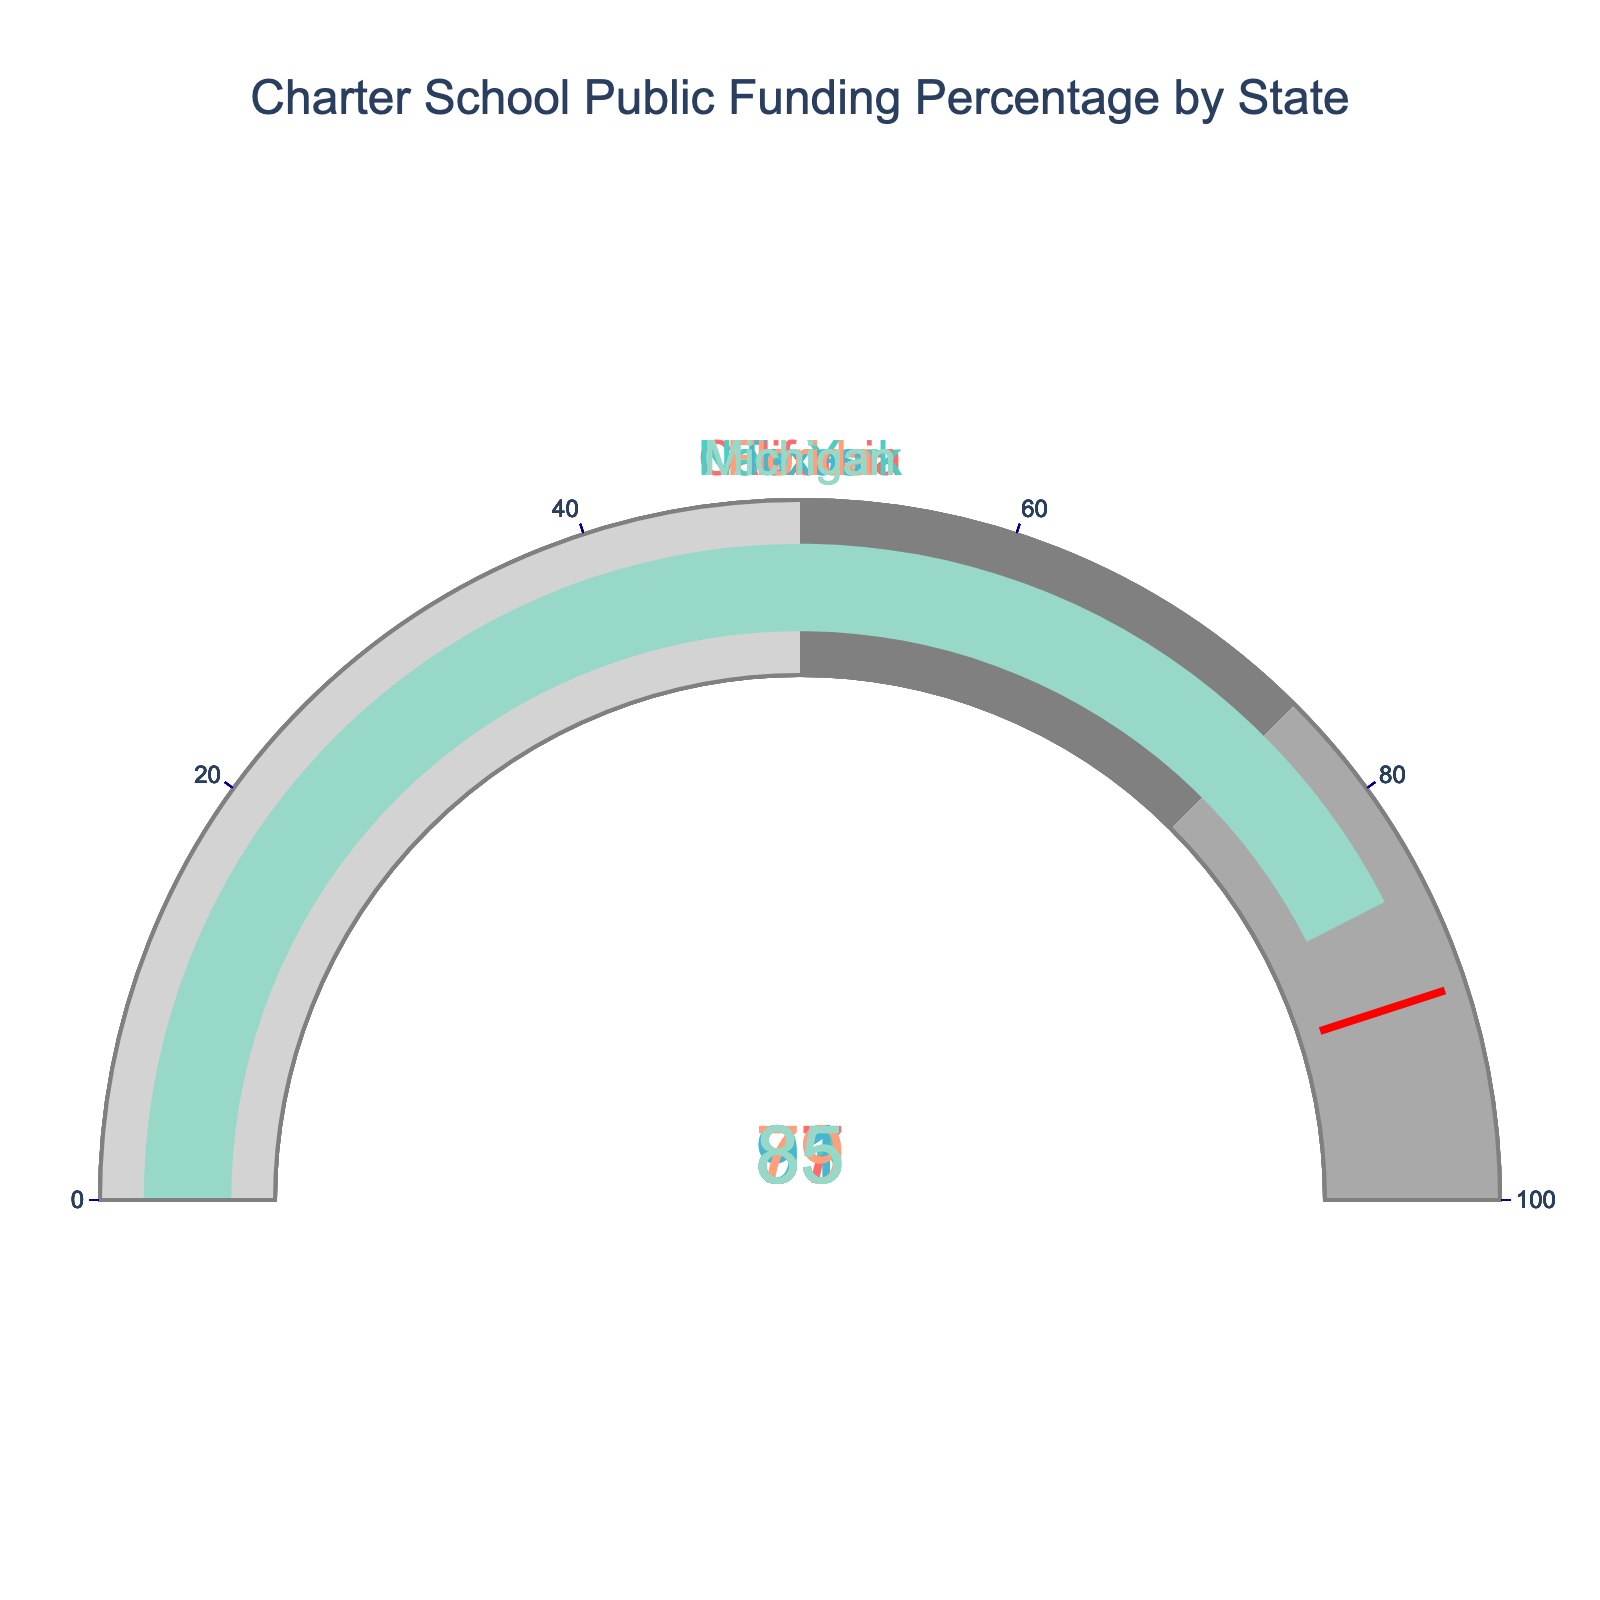what is the title of the figure? The title is displayed at the top of the figure, written in large font. It reads "Charter School Public Funding Percentage by State".
Answer: Charter School Public Funding Percentage by State Which state has the highest percentage of charter school funding from public sources? By looking at the gauge chart, you can compare the displayed percentages for each state. Texas has the highest value, which is 91%.
Answer: Texas How many states have more than 80% of their charter school funding coming from public sources? Look at the percentages on the gauge charts for each state. California (87%), New York (83%), Texas (91%), and Michigan (85%) all exceed 80%.
Answer: 4 Which state has the lowest percentage of public funding for charter schools? Compare the values on each gauge chart. Florida, with 79%, has the lowest percentage.
Answer: Florida What's the average percentage of charter school funding from public sources across all the states shown? Sum the percentages for each state (87 + 83 + 91 + 79 + 85 = 425) and divide by the number of states (5). The average percentage is 425/5 = 85%.
Answer: 85% Are there any states where the threshold set at 90% is surpassed? Examine each gauge chart to see if any value exceeds the red threshold line set at 90%. Only Texas, with 91%, surpasses this threshold.
Answer: Yes, Texas What is the difference in public funding percentages between the states with the highest and lowest values? Find the highest value (Texas, 91%) and the lowest value (Florida, 79%). Subtract the lowest from the highest: 91% - 79% = 12%.
Answer: 12% How many states have percentages within the 50-75% range? Examine the gauge charts and note the colors and ranges. No states fall within this medium range as all percentages are above 75%.
Answer: 0 Is there any gauge that displays a public funding percentage exactly at the threshold? Look at the gauge charts and note if any state’s percentage aligns with the red threshold line at 90%. None of the states have exactly 90%.
Answer: No Which states have a public funding percentage greater than the average percentage? The average percentage calculated is 85%. Compare each state's percentage to see if it is greater. California (87%), Texas (91%), and Michigan (85%) all meet this criterion.
Answer: California, Texas, Michigan 